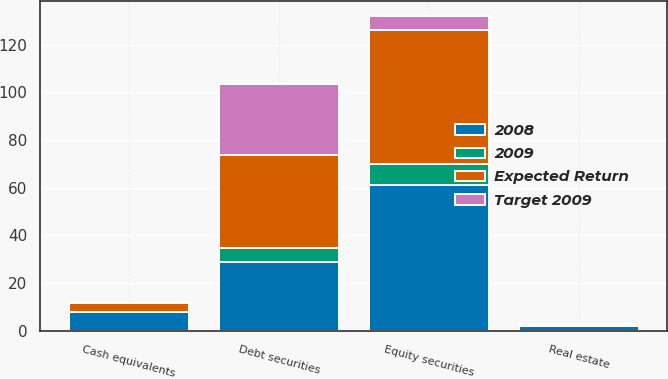<chart> <loc_0><loc_0><loc_500><loc_500><stacked_bar_chart><ecel><fcel>Equity securities<fcel>Debt securities<fcel>Real estate<fcel>Cash equivalents<nl><fcel>Expected Return<fcel>56<fcel>39<fcel>1<fcel>4<nl><fcel>2008<fcel>61.1<fcel>29<fcel>2.1<fcel>7.8<nl><fcel>Target 2009<fcel>5.7<fcel>30<fcel>0<fcel>0<nl><fcel>2009<fcel>9<fcel>5.7<fcel>0<fcel>0<nl></chart> 